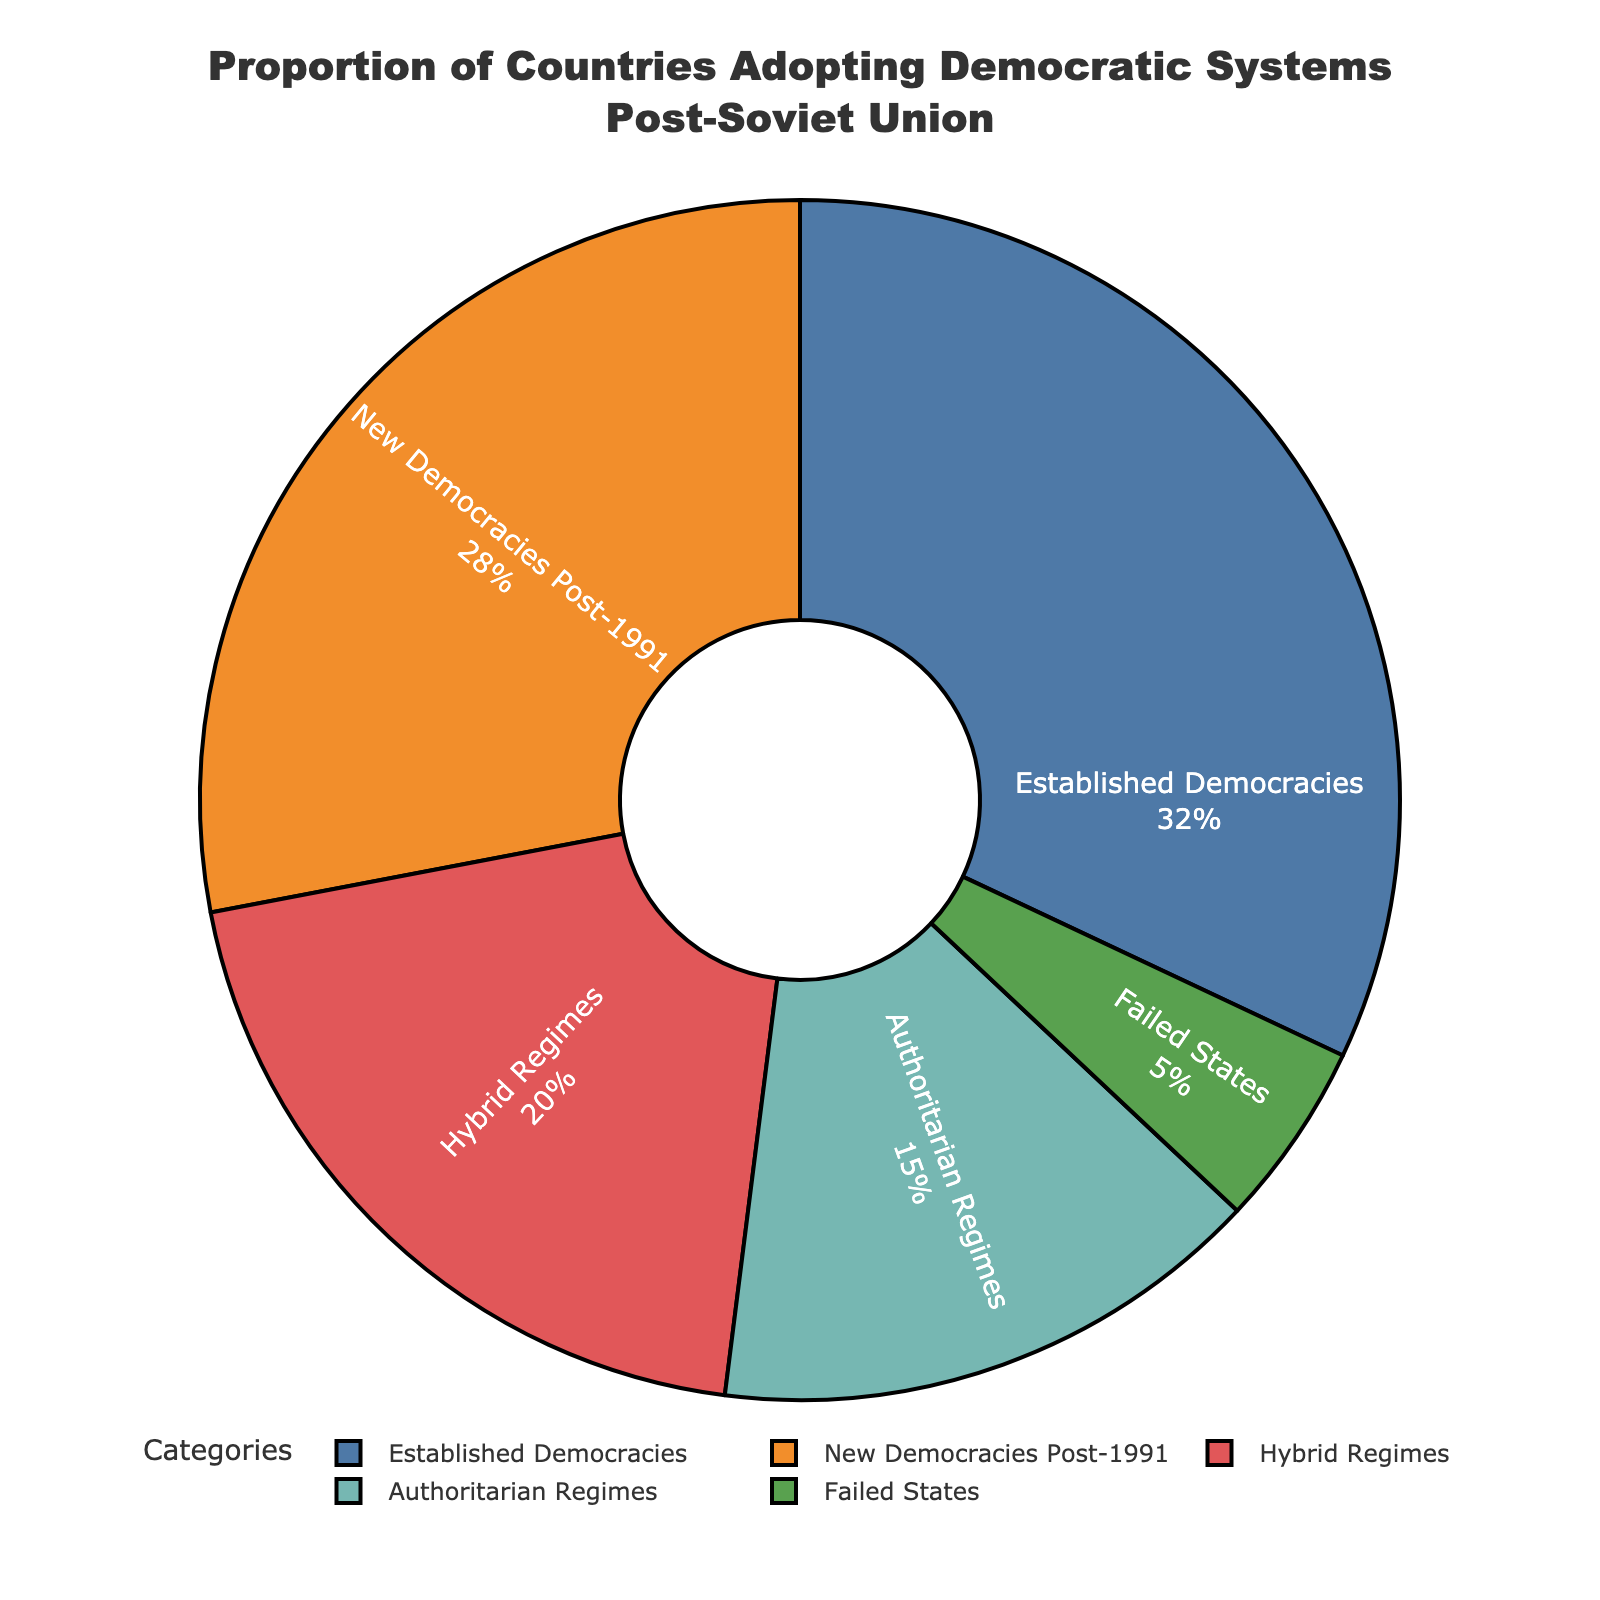What percentage of countries are either established democracies or new democracies post-1991? To solve this, add the percentage of Established Democracies (32%) and New Democracies Post-1991 (28%). This results in 32% + 28% = 60%.
Answer: 60% Which category has the smallest proportion of countries? Look at the percentages in the pie chart and find the category with the lowest value. The Failed States category has the smallest proportion at 5%.
Answer: Failed States Is the proportion of hybrid regimes greater than that of authoritarian regimes? Compare the percentages for Hybrid Regimes (20%) and Authoritarian Regimes (15%). Since 20% is greater than 15%, the answer is yes.
Answer: Yes How does the proportion of hybrid regimes compare to the proportion of failed states? Compare the percentage for Hybrid Regimes (20%) with that for Failed States (5%). Since 20% is greater than 5%, Hybrid Regimes have a higher proportion.
Answer: Greater What is the combined percentage of hybrid regimes and authoritarian regimes? Add the percentage of Hybrid Regimes (20%) and Authoritarian Regimes (15%). This results in 20% + 15% = 35%.
Answer: 35% Which has a higher percentage: new democracies post-1991 or authoritarian regimes? Compare the percentages for New Democracies Post-1991 (28%) and Authoritarian Regimes (15%). New Democracies post-1991 have a higher percentage than Authoritarian Regimes.
Answer: New Democracies Post-1991 What percentage of countries are not established democracies? Subtract the percentage of Established Democracies (32%) from 100%. This gives 100% - 32% = 68%.
Answer: 68% Between new democracies post-1991 and hybrid regimes, which category has the larger proportion? Compare the percentages for New Democracies Post-1991 (28%) and Hybrid Regimes (20%). New Democracies Post-1991 have a larger proportion.
Answer: New Democracies Post-1991 What color represents established democracies on the pie chart? According to the figure's color scheme, Established Democracies are represented by the color blue.
Answer: Blue 